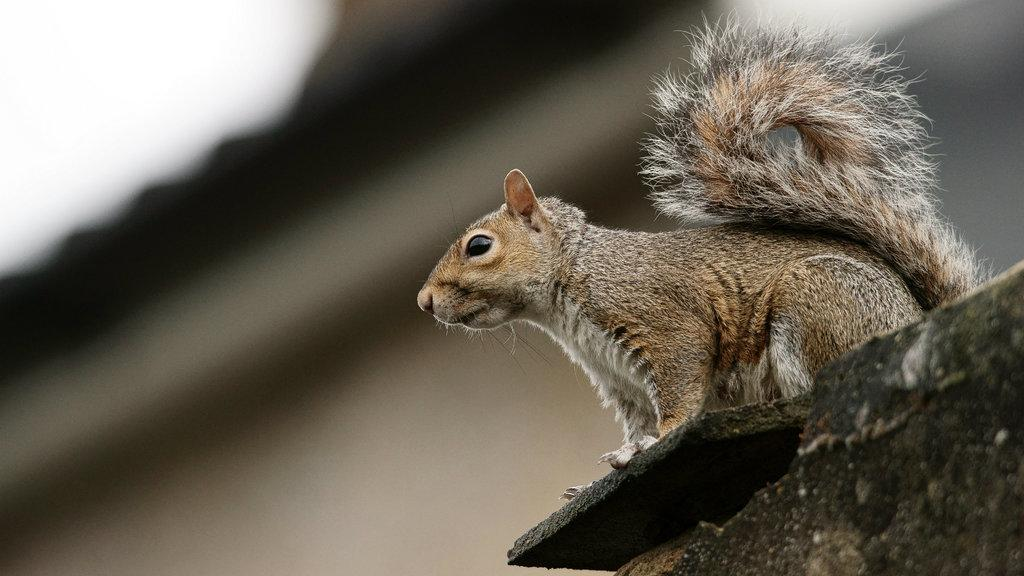What type of creature is present in the image? There is an animal in the image. Can you describe the color of the animal? The animal is brown in color. What can be observed about the background of the image? The background of the image is blurred. What news is the grandfather reading in the image? There is no grandfather or news present in the image; it features an animal with a blurred background. 